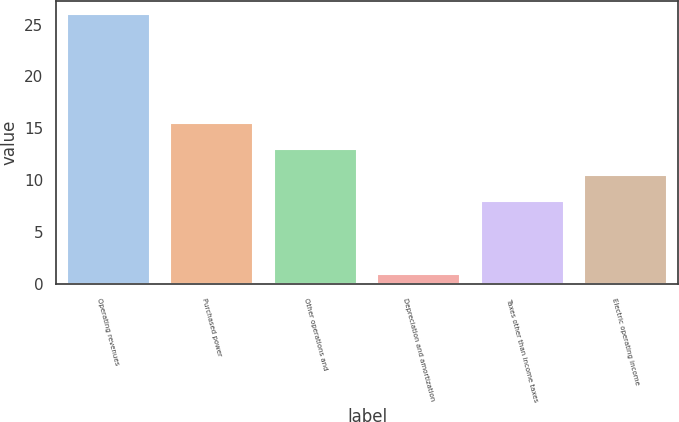Convert chart to OTSL. <chart><loc_0><loc_0><loc_500><loc_500><bar_chart><fcel>Operating revenues<fcel>Purchased power<fcel>Other operations and<fcel>Depreciation and amortization<fcel>Taxes other than income taxes<fcel>Electric operating income<nl><fcel>26<fcel>15.5<fcel>13<fcel>1<fcel>8<fcel>10.5<nl></chart> 